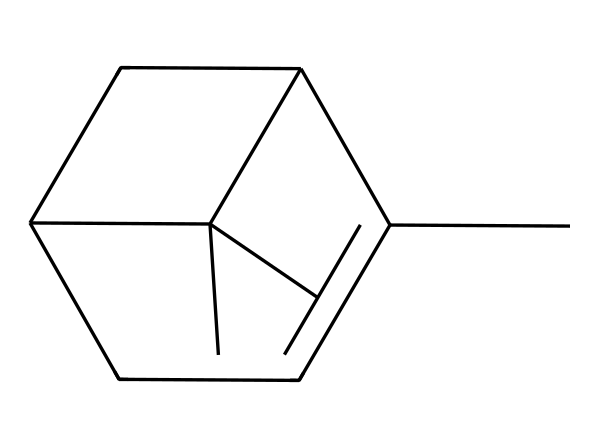What is the molecular formula of pinene? The SMILES representation can be converted to determine the molecular formula. In the structure, we identify the carbon (C) and hydrogen (H) atoms. Counting the carbon atoms gives us 10 and counting hydrogen atoms gives us 16. Therefore, the molecular formula is C10H16.
Answer: C10H16 How many rings are present in the structure of pinene? By examining the structure represented by the SMILES notation, we need to look for cyclic components in the chemical. The notation shows that there are two ring structures present in this molecule.
Answer: 2 What type of isomerism is displayed by pinene? Pinene exists in two structural forms: alpha (α) and beta (β) pinene, which are geometrical isomers. This is due to differences in the arrangement of atoms in a three-dimensional space, thus showcasing stereoisomerism.
Answer: stereoisomerism What is the primary functional group in pinene? Analyzing the structure, pinene contains a carbon-carbon double bond, which is characteristic of alkenes. Thus, the primary functional group observed is that of an alkene.
Answer: alkene How many chiral centers are present in pinene? To identify chiral centers, we look for carbon atoms that are bonded to four different substituents. Upon examining the skeletal structure derived from the SMILES representation, there is one such carbon, indicating one chiral center.
Answer: 1 What is the relationship between pinene and pine trees? Pinene is a significant component of the essential oils found in pine trees, contributing to their scent and potentially impacting forest ecology; thus, it is linked to forest conservation efforts.
Answer: significant component 